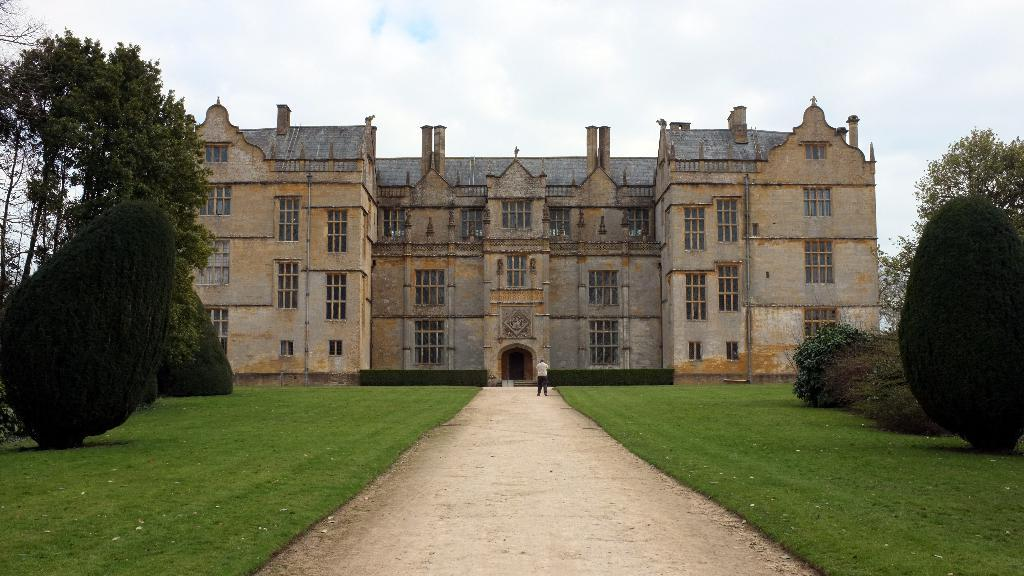What type of vegetation can be seen in the image? There is grass, plants, and trees in the image. What type of surface is visible in the image? There is ground in the image. What type of structure is present in the image? There is a building in the image. Who or what is present in the image? There is a person in the image. What is visible in the background of the image? The sky is visible in the background of the image, and there are clouds in the sky. What is the person's income in the image? There is no information about the person's income in the image. Can you tell me how the person is using a skate in the image? There is no skate present in the image. 